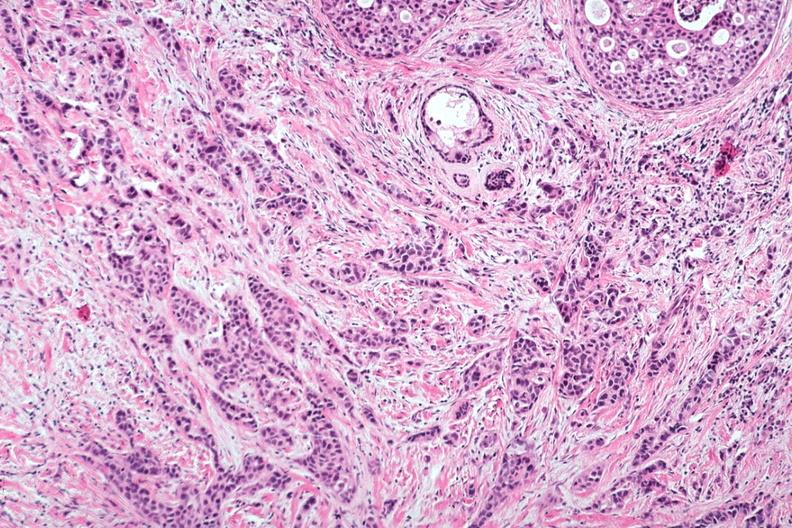what is present?
Answer the question using a single word or phrase. Papillary intraductal adenocarcinoma 